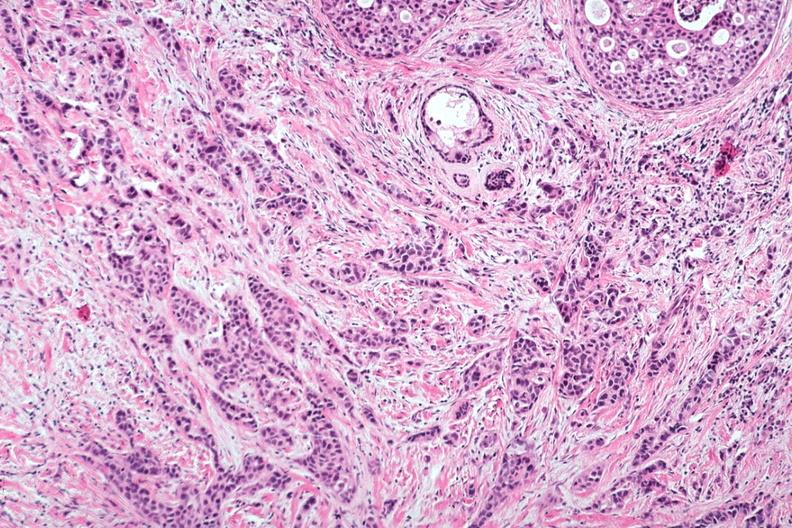what is present?
Answer the question using a single word or phrase. Papillary intraductal adenocarcinoma 